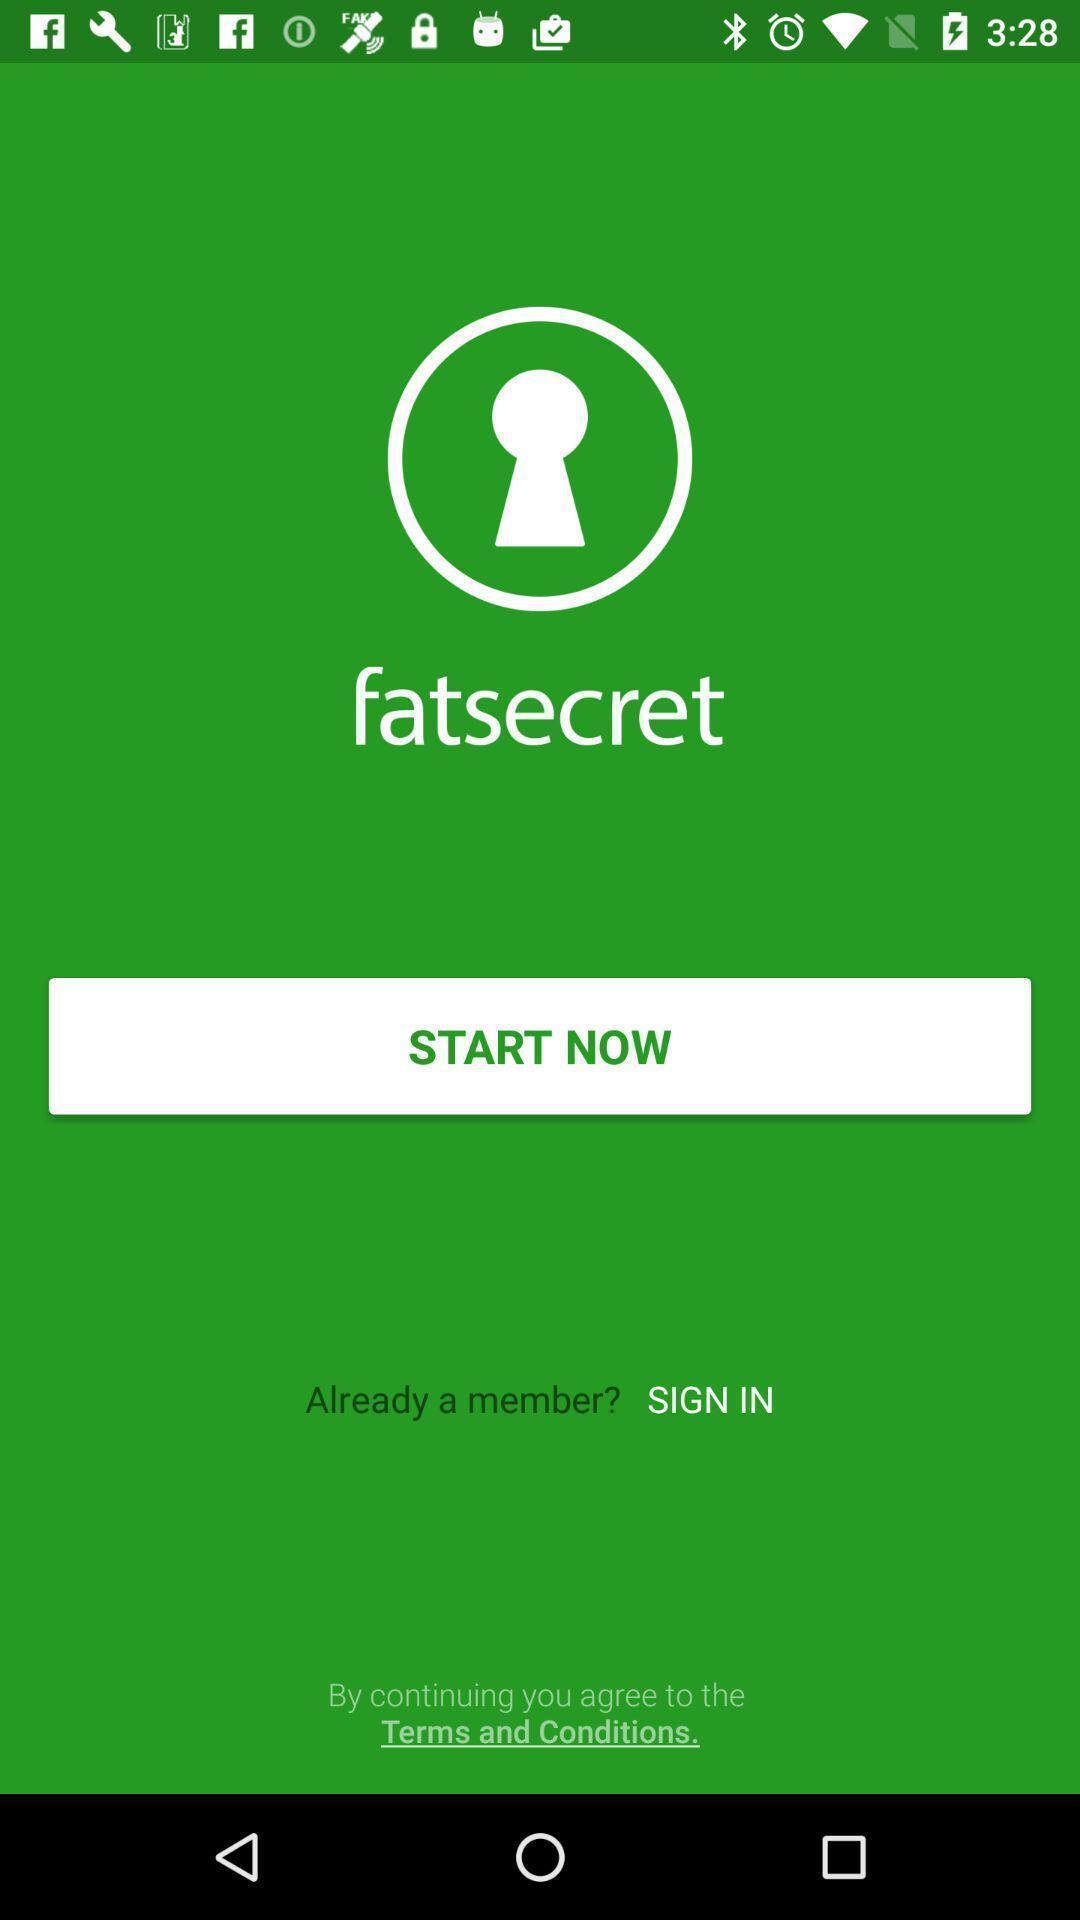Tell me about the visual elements in this screen capture. Window displaying an dieting app. 